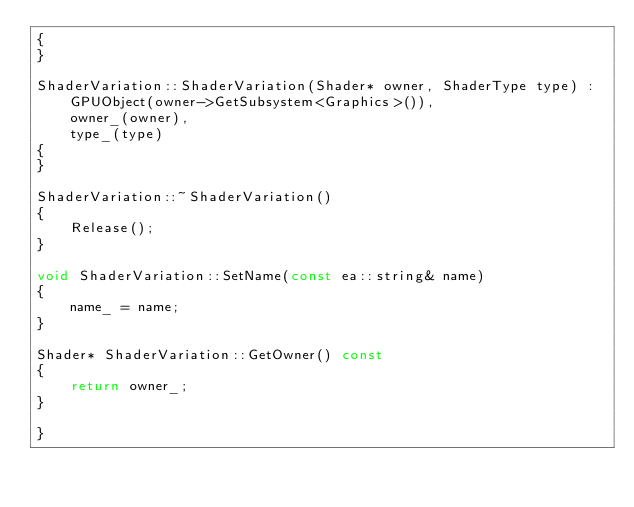Convert code to text. <code><loc_0><loc_0><loc_500><loc_500><_C++_>{
}

ShaderVariation::ShaderVariation(Shader* owner, ShaderType type) :
    GPUObject(owner->GetSubsystem<Graphics>()),
    owner_(owner),
    type_(type)
{
}

ShaderVariation::~ShaderVariation()
{
    Release();
}

void ShaderVariation::SetName(const ea::string& name)
{
    name_ = name;
}

Shader* ShaderVariation::GetOwner() const
{
    return owner_;
}

}
</code> 